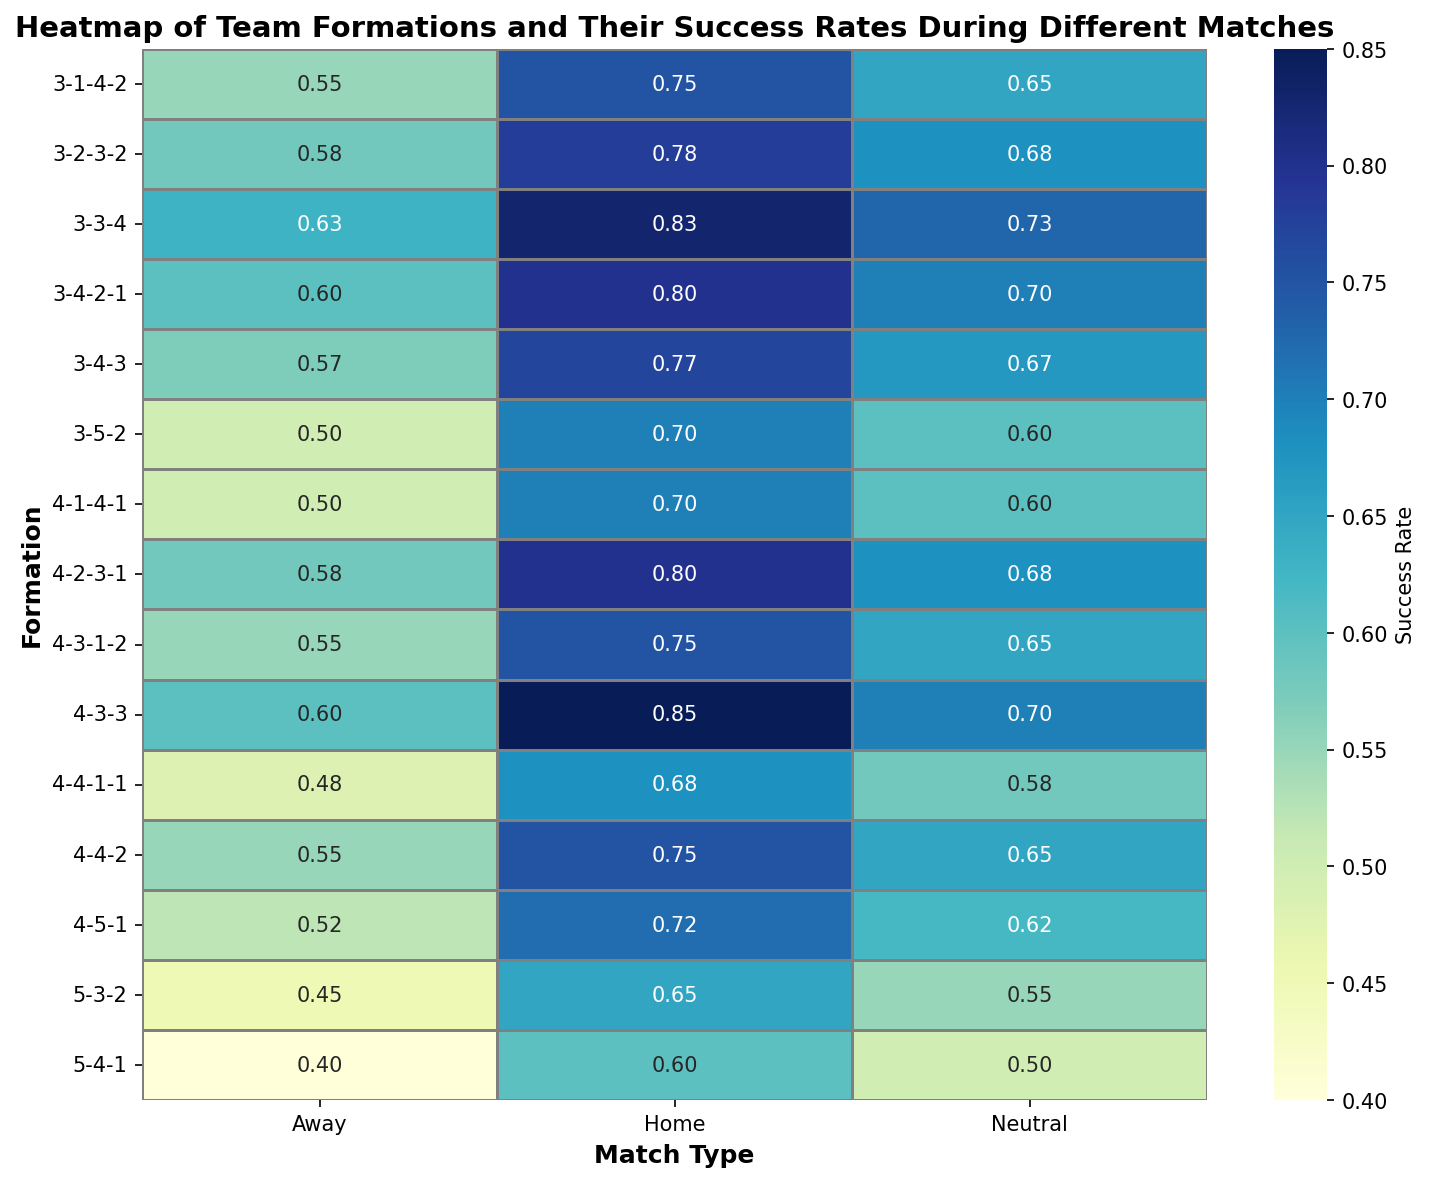Which formation has the highest success rate at home and what is that rate? Look at the "Home" column and identify the formation with the darkest color, indicating the highest rate. The formation 4-3-3 has the highest success rate at home with a rate of 0.85
Answer: 4-3-3, 0.85 Which formation has the lowest success rate away and what is that rate? Check the "Away" column for the lightest color, which signifies the lowest rate. The 5-4-1 formation has the lowest success rate away with a rate of 0.40.
Answer: 5-4-1, 0.40 Which formation shows the most consistent success rates across all match types? Consistency can be evaluated by looking at formations where the differences in color between their Home, Away, and Neutral columns are minimal. The 4-4-2 formation shows consistent success rates of 0.75, 0.55, and 0.65.
Answer: 4-4-2 What is the average success rate for the 3-3-4 formation? Add up the success rates of the 3-3-4 formation and divide by 3: (0.83 + 0.63 + 0.73) / 3 = 0.73
Answer: 0.73 Which formations have a success rate exactly 0.50 in any of the match types? Scan the heatmap for cells with the value 0.50. Formations are 3-5-2 in Away and 4-1-4-1 in Away
Answer: 3-5-2, 4-1-4-1 How many formations have a higher success rate at home compared to away? For each formation, compare the success rates between the Home and Away columns. Count the formations with higher values in the Home column. There are 15 formations with higher success rates at home.
Answer: 15 Compare the success rates of 3-4-3 and 4-2-3-1 for Neutral matches. Which one is higher and by how much? Identify the Neutral success rates for both formations: 3-4-3 has 0.67, and 4-2-3-1 has 0.68. Subtract the smaller value from the larger value: 0.68 - 0.67 = 0.01
Answer: 4-2-3-1, 0.01 What is the success rate difference for the 4-4-1-1 formation between home and away matches? Subtract the Away success rate from the Home success rate for the 4-4-1-1 formation: 0.68 - 0.48 = 0.20
Answer: 0.20 Which match type generally shows the highest success rates across all formations? Compare the overall darker shades in columns: the Home column generally has darker shades.
Answer: Home For the 3-2-3-2 formation, by how much does the success rate increase from Away to Neutral matches? Subtract the Away success rate from the Neutral success rate for the 3-2-3-2 formation: 0.68 - 0.58 = 0.10
Answer: 0.10 